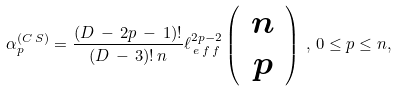Convert formula to latex. <formula><loc_0><loc_0><loc_500><loc_500>\alpha _ { p } ^ { ( C \, S ) } = \frac { ( D \, - \, 2 p \, - \, 1 ) ! } { ( D \, - \, 3 ) ! \, n } \ell _ { \, e \, f \, f } ^ { 2 p - 2 } \left ( \, \begin{array} { c } n \\ p \end{array} \, \right ) \, , \, 0 \leq p \leq n ,</formula> 